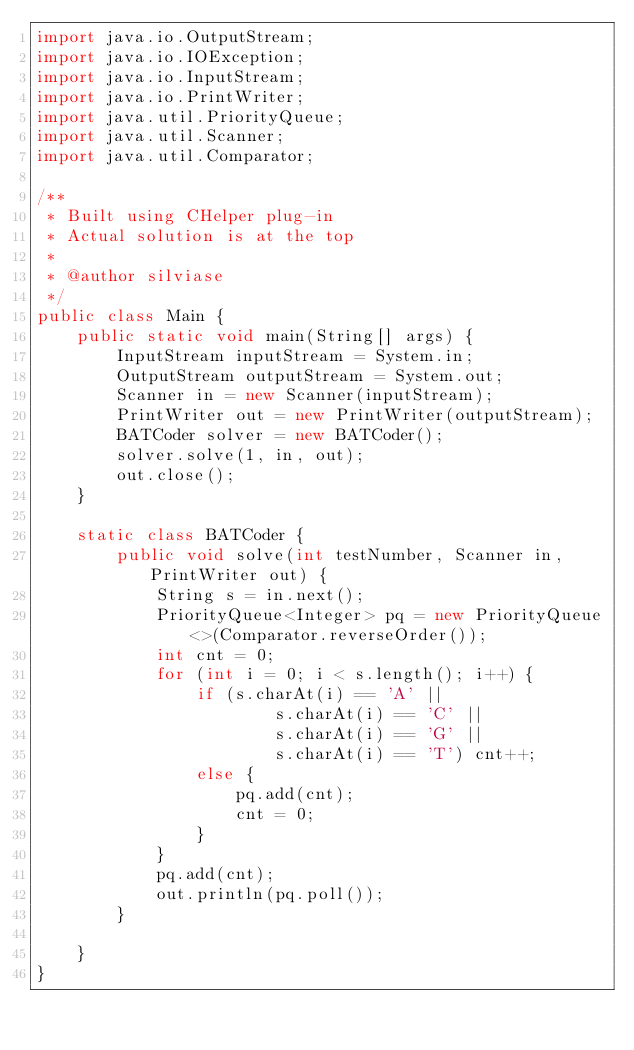Convert code to text. <code><loc_0><loc_0><loc_500><loc_500><_Java_>import java.io.OutputStream;
import java.io.IOException;
import java.io.InputStream;
import java.io.PrintWriter;
import java.util.PriorityQueue;
import java.util.Scanner;
import java.util.Comparator;

/**
 * Built using CHelper plug-in
 * Actual solution is at the top
 *
 * @author silviase
 */
public class Main {
    public static void main(String[] args) {
        InputStream inputStream = System.in;
        OutputStream outputStream = System.out;
        Scanner in = new Scanner(inputStream);
        PrintWriter out = new PrintWriter(outputStream);
        BATCoder solver = new BATCoder();
        solver.solve(1, in, out);
        out.close();
    }

    static class BATCoder {
        public void solve(int testNumber, Scanner in, PrintWriter out) {
            String s = in.next();
            PriorityQueue<Integer> pq = new PriorityQueue<>(Comparator.reverseOrder());
            int cnt = 0;
            for (int i = 0; i < s.length(); i++) {
                if (s.charAt(i) == 'A' ||
                        s.charAt(i) == 'C' ||
                        s.charAt(i) == 'G' ||
                        s.charAt(i) == 'T') cnt++;
                else {
                    pq.add(cnt);
                    cnt = 0;
                }
            }
            pq.add(cnt);
            out.println(pq.poll());
        }

    }
}

</code> 